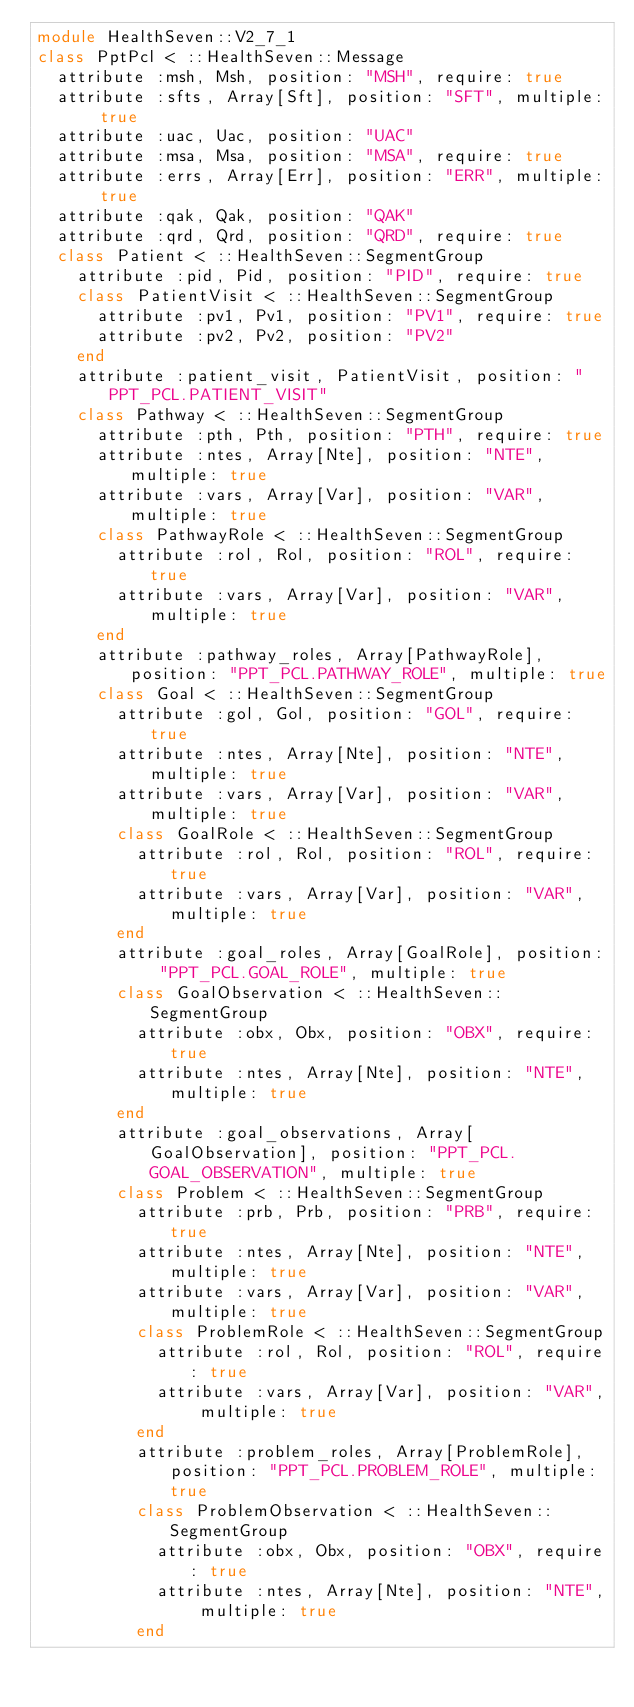Convert code to text. <code><loc_0><loc_0><loc_500><loc_500><_Ruby_>module HealthSeven::V2_7_1
class PptPcl < ::HealthSeven::Message
  attribute :msh, Msh, position: "MSH", require: true
  attribute :sfts, Array[Sft], position: "SFT", multiple: true
  attribute :uac, Uac, position: "UAC"
  attribute :msa, Msa, position: "MSA", require: true
  attribute :errs, Array[Err], position: "ERR", multiple: true
  attribute :qak, Qak, position: "QAK"
  attribute :qrd, Qrd, position: "QRD", require: true
  class Patient < ::HealthSeven::SegmentGroup
    attribute :pid, Pid, position: "PID", require: true
    class PatientVisit < ::HealthSeven::SegmentGroup
      attribute :pv1, Pv1, position: "PV1", require: true
      attribute :pv2, Pv2, position: "PV2"
    end
    attribute :patient_visit, PatientVisit, position: "PPT_PCL.PATIENT_VISIT"
    class Pathway < ::HealthSeven::SegmentGroup
      attribute :pth, Pth, position: "PTH", require: true
      attribute :ntes, Array[Nte], position: "NTE", multiple: true
      attribute :vars, Array[Var], position: "VAR", multiple: true
      class PathwayRole < ::HealthSeven::SegmentGroup
        attribute :rol, Rol, position: "ROL", require: true
        attribute :vars, Array[Var], position: "VAR", multiple: true
      end
      attribute :pathway_roles, Array[PathwayRole], position: "PPT_PCL.PATHWAY_ROLE", multiple: true
      class Goal < ::HealthSeven::SegmentGroup
        attribute :gol, Gol, position: "GOL", require: true
        attribute :ntes, Array[Nte], position: "NTE", multiple: true
        attribute :vars, Array[Var], position: "VAR", multiple: true
        class GoalRole < ::HealthSeven::SegmentGroup
          attribute :rol, Rol, position: "ROL", require: true
          attribute :vars, Array[Var], position: "VAR", multiple: true
        end
        attribute :goal_roles, Array[GoalRole], position: "PPT_PCL.GOAL_ROLE", multiple: true
        class GoalObservation < ::HealthSeven::SegmentGroup
          attribute :obx, Obx, position: "OBX", require: true
          attribute :ntes, Array[Nte], position: "NTE", multiple: true
        end
        attribute :goal_observations, Array[GoalObservation], position: "PPT_PCL.GOAL_OBSERVATION", multiple: true
        class Problem < ::HealthSeven::SegmentGroup
          attribute :prb, Prb, position: "PRB", require: true
          attribute :ntes, Array[Nte], position: "NTE", multiple: true
          attribute :vars, Array[Var], position: "VAR", multiple: true
          class ProblemRole < ::HealthSeven::SegmentGroup
            attribute :rol, Rol, position: "ROL", require: true
            attribute :vars, Array[Var], position: "VAR", multiple: true
          end
          attribute :problem_roles, Array[ProblemRole], position: "PPT_PCL.PROBLEM_ROLE", multiple: true
          class ProblemObservation < ::HealthSeven::SegmentGroup
            attribute :obx, Obx, position: "OBX", require: true
            attribute :ntes, Array[Nte], position: "NTE", multiple: true
          end</code> 